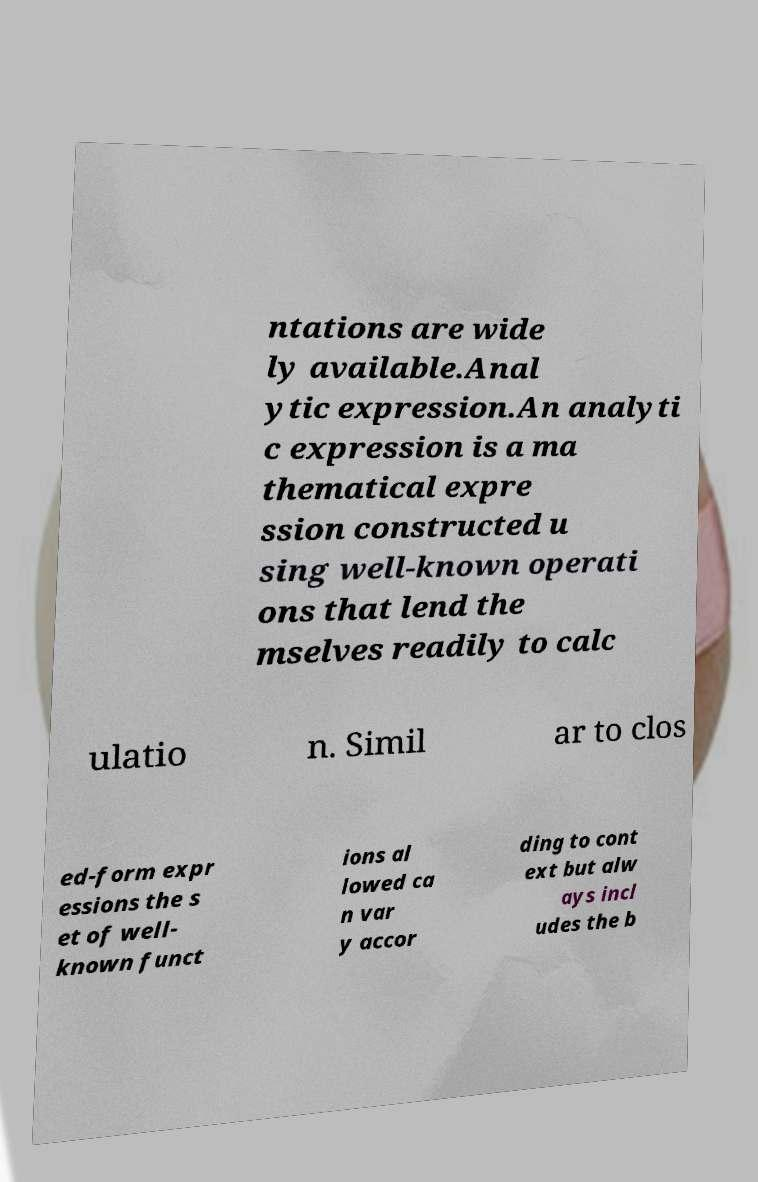What messages or text are displayed in this image? I need them in a readable, typed format. ntations are wide ly available.Anal ytic expression.An analyti c expression is a ma thematical expre ssion constructed u sing well-known operati ons that lend the mselves readily to calc ulatio n. Simil ar to clos ed-form expr essions the s et of well- known funct ions al lowed ca n var y accor ding to cont ext but alw ays incl udes the b 